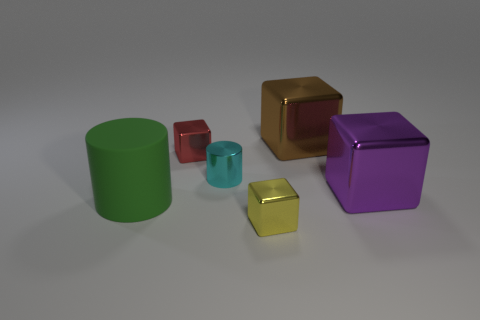Add 1 brown metallic things. How many objects exist? 7 Subtract all cylinders. How many objects are left? 4 Subtract 0 blue blocks. How many objects are left? 6 Subtract all small blue spheres. Subtract all big green rubber things. How many objects are left? 5 Add 2 big green things. How many big green things are left? 3 Add 1 matte cubes. How many matte cubes exist? 1 